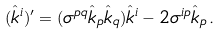Convert formula to latex. <formula><loc_0><loc_0><loc_500><loc_500>( \hat { k } ^ { i } ) ^ { \prime } = ( \sigma ^ { p q } \hat { k } _ { p } \hat { k } _ { q } ) \hat { k } ^ { i } - 2 \sigma ^ { i p } \hat { k } _ { p } \, .</formula> 